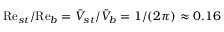<formula> <loc_0><loc_0><loc_500><loc_500>R e _ { s t } / R e _ { b } = \bar { V } _ { s t } / \bar { V } _ { b } = 1 / ( 2 \pi ) \approx 0 . 1 6</formula> 